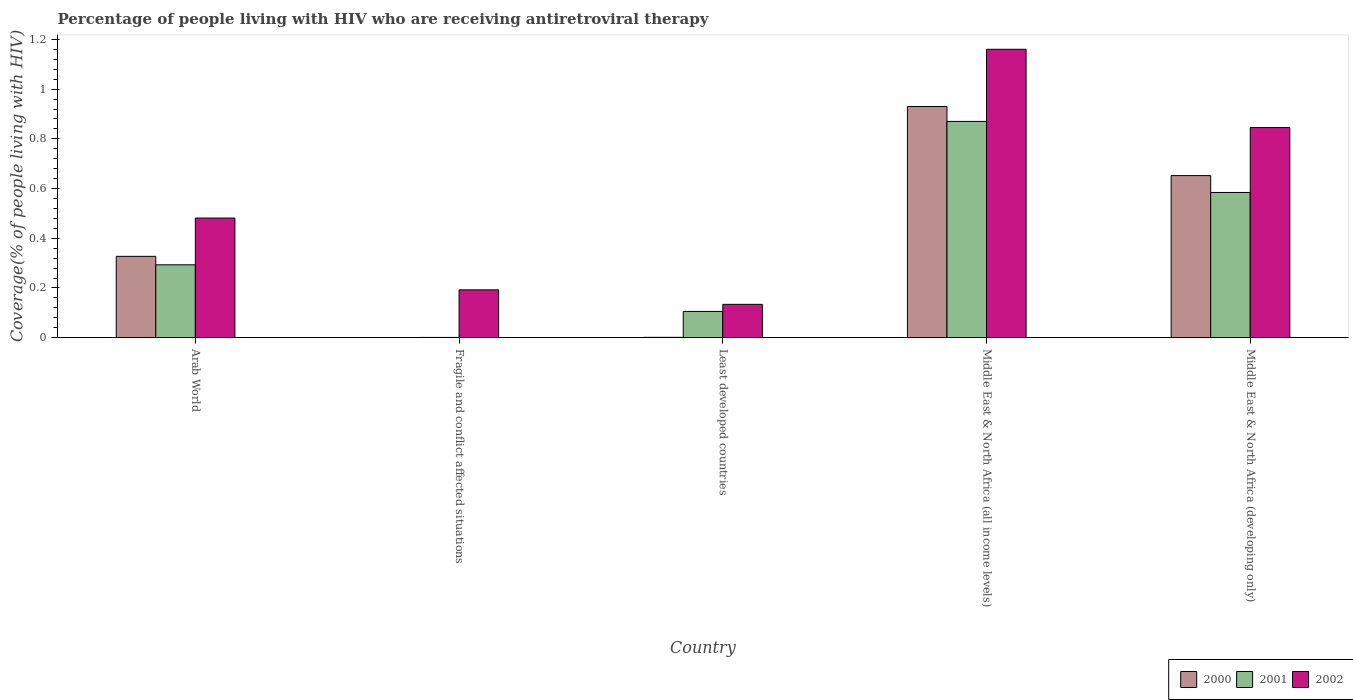Are the number of bars on each tick of the X-axis equal?
Provide a succinct answer. Yes. How many bars are there on the 1st tick from the right?
Keep it short and to the point. 3. What is the label of the 4th group of bars from the left?
Keep it short and to the point. Middle East & North Africa (all income levels). What is the percentage of the HIV infected people who are receiving antiretroviral therapy in 2002 in Least developed countries?
Make the answer very short. 0.13. Across all countries, what is the maximum percentage of the HIV infected people who are receiving antiretroviral therapy in 2001?
Ensure brevity in your answer.  0.87. Across all countries, what is the minimum percentage of the HIV infected people who are receiving antiretroviral therapy in 2001?
Give a very brief answer. 0. In which country was the percentage of the HIV infected people who are receiving antiretroviral therapy in 2002 maximum?
Provide a succinct answer. Middle East & North Africa (all income levels). In which country was the percentage of the HIV infected people who are receiving antiretroviral therapy in 2000 minimum?
Your response must be concise. Fragile and conflict affected situations. What is the total percentage of the HIV infected people who are receiving antiretroviral therapy in 2001 in the graph?
Make the answer very short. 1.85. What is the difference between the percentage of the HIV infected people who are receiving antiretroviral therapy in 2000 in Middle East & North Africa (all income levels) and that in Middle East & North Africa (developing only)?
Keep it short and to the point. 0.28. What is the difference between the percentage of the HIV infected people who are receiving antiretroviral therapy in 2002 in Middle East & North Africa (developing only) and the percentage of the HIV infected people who are receiving antiretroviral therapy in 2000 in Fragile and conflict affected situations?
Ensure brevity in your answer.  0.85. What is the average percentage of the HIV infected people who are receiving antiretroviral therapy in 2000 per country?
Give a very brief answer. 0.38. What is the difference between the percentage of the HIV infected people who are receiving antiretroviral therapy of/in 2001 and percentage of the HIV infected people who are receiving antiretroviral therapy of/in 2002 in Fragile and conflict affected situations?
Give a very brief answer. -0.19. What is the ratio of the percentage of the HIV infected people who are receiving antiretroviral therapy in 2002 in Arab World to that in Fragile and conflict affected situations?
Provide a short and direct response. 2.5. Is the percentage of the HIV infected people who are receiving antiretroviral therapy in 2000 in Fragile and conflict affected situations less than that in Middle East & North Africa (all income levels)?
Offer a very short reply. Yes. Is the difference between the percentage of the HIV infected people who are receiving antiretroviral therapy in 2001 in Least developed countries and Middle East & North Africa (developing only) greater than the difference between the percentage of the HIV infected people who are receiving antiretroviral therapy in 2002 in Least developed countries and Middle East & North Africa (developing only)?
Provide a short and direct response. Yes. What is the difference between the highest and the second highest percentage of the HIV infected people who are receiving antiretroviral therapy in 2000?
Your answer should be compact. 0.28. What is the difference between the highest and the lowest percentage of the HIV infected people who are receiving antiretroviral therapy in 2001?
Offer a terse response. 0.87. In how many countries, is the percentage of the HIV infected people who are receiving antiretroviral therapy in 2002 greater than the average percentage of the HIV infected people who are receiving antiretroviral therapy in 2002 taken over all countries?
Give a very brief answer. 2. What does the 2nd bar from the left in Fragile and conflict affected situations represents?
Offer a very short reply. 2001. What does the 2nd bar from the right in Middle East & North Africa (developing only) represents?
Offer a very short reply. 2001. Is it the case that in every country, the sum of the percentage of the HIV infected people who are receiving antiretroviral therapy in 2000 and percentage of the HIV infected people who are receiving antiretroviral therapy in 2001 is greater than the percentage of the HIV infected people who are receiving antiretroviral therapy in 2002?
Provide a succinct answer. No. Are the values on the major ticks of Y-axis written in scientific E-notation?
Provide a short and direct response. No. Does the graph contain grids?
Give a very brief answer. No. Where does the legend appear in the graph?
Provide a short and direct response. Bottom right. How many legend labels are there?
Provide a short and direct response. 3. What is the title of the graph?
Your answer should be very brief. Percentage of people living with HIV who are receiving antiretroviral therapy. What is the label or title of the Y-axis?
Offer a very short reply. Coverage(% of people living with HIV). What is the Coverage(% of people living with HIV) in 2000 in Arab World?
Offer a very short reply. 0.33. What is the Coverage(% of people living with HIV) in 2001 in Arab World?
Offer a very short reply. 0.29. What is the Coverage(% of people living with HIV) in 2002 in Arab World?
Provide a short and direct response. 0.48. What is the Coverage(% of people living with HIV) of 2000 in Fragile and conflict affected situations?
Keep it short and to the point. 0. What is the Coverage(% of people living with HIV) in 2001 in Fragile and conflict affected situations?
Your answer should be very brief. 0. What is the Coverage(% of people living with HIV) in 2002 in Fragile and conflict affected situations?
Provide a succinct answer. 0.19. What is the Coverage(% of people living with HIV) of 2000 in Least developed countries?
Ensure brevity in your answer.  0. What is the Coverage(% of people living with HIV) of 2001 in Least developed countries?
Ensure brevity in your answer.  0.11. What is the Coverage(% of people living with HIV) in 2002 in Least developed countries?
Give a very brief answer. 0.13. What is the Coverage(% of people living with HIV) in 2000 in Middle East & North Africa (all income levels)?
Your response must be concise. 0.93. What is the Coverage(% of people living with HIV) of 2001 in Middle East & North Africa (all income levels)?
Offer a terse response. 0.87. What is the Coverage(% of people living with HIV) of 2002 in Middle East & North Africa (all income levels)?
Your response must be concise. 1.16. What is the Coverage(% of people living with HIV) in 2000 in Middle East & North Africa (developing only)?
Your answer should be compact. 0.65. What is the Coverage(% of people living with HIV) in 2001 in Middle East & North Africa (developing only)?
Your answer should be very brief. 0.58. What is the Coverage(% of people living with HIV) in 2002 in Middle East & North Africa (developing only)?
Your response must be concise. 0.85. Across all countries, what is the maximum Coverage(% of people living with HIV) in 2000?
Provide a short and direct response. 0.93. Across all countries, what is the maximum Coverage(% of people living with HIV) of 2001?
Offer a very short reply. 0.87. Across all countries, what is the maximum Coverage(% of people living with HIV) of 2002?
Make the answer very short. 1.16. Across all countries, what is the minimum Coverage(% of people living with HIV) in 2000?
Provide a short and direct response. 0. Across all countries, what is the minimum Coverage(% of people living with HIV) of 2001?
Your answer should be very brief. 0. Across all countries, what is the minimum Coverage(% of people living with HIV) in 2002?
Your response must be concise. 0.13. What is the total Coverage(% of people living with HIV) of 2000 in the graph?
Keep it short and to the point. 1.91. What is the total Coverage(% of people living with HIV) of 2001 in the graph?
Offer a very short reply. 1.85. What is the total Coverage(% of people living with HIV) in 2002 in the graph?
Offer a terse response. 2.81. What is the difference between the Coverage(% of people living with HIV) in 2000 in Arab World and that in Fragile and conflict affected situations?
Your response must be concise. 0.33. What is the difference between the Coverage(% of people living with HIV) in 2001 in Arab World and that in Fragile and conflict affected situations?
Offer a very short reply. 0.29. What is the difference between the Coverage(% of people living with HIV) of 2002 in Arab World and that in Fragile and conflict affected situations?
Offer a very short reply. 0.29. What is the difference between the Coverage(% of people living with HIV) of 2000 in Arab World and that in Least developed countries?
Give a very brief answer. 0.33. What is the difference between the Coverage(% of people living with HIV) in 2001 in Arab World and that in Least developed countries?
Ensure brevity in your answer.  0.19. What is the difference between the Coverage(% of people living with HIV) of 2002 in Arab World and that in Least developed countries?
Your answer should be very brief. 0.35. What is the difference between the Coverage(% of people living with HIV) in 2000 in Arab World and that in Middle East & North Africa (all income levels)?
Your response must be concise. -0.6. What is the difference between the Coverage(% of people living with HIV) in 2001 in Arab World and that in Middle East & North Africa (all income levels)?
Give a very brief answer. -0.58. What is the difference between the Coverage(% of people living with HIV) in 2002 in Arab World and that in Middle East & North Africa (all income levels)?
Ensure brevity in your answer.  -0.68. What is the difference between the Coverage(% of people living with HIV) of 2000 in Arab World and that in Middle East & North Africa (developing only)?
Provide a short and direct response. -0.32. What is the difference between the Coverage(% of people living with HIV) of 2001 in Arab World and that in Middle East & North Africa (developing only)?
Provide a succinct answer. -0.29. What is the difference between the Coverage(% of people living with HIV) of 2002 in Arab World and that in Middle East & North Africa (developing only)?
Provide a succinct answer. -0.36. What is the difference between the Coverage(% of people living with HIV) in 2000 in Fragile and conflict affected situations and that in Least developed countries?
Give a very brief answer. -0. What is the difference between the Coverage(% of people living with HIV) of 2001 in Fragile and conflict affected situations and that in Least developed countries?
Your answer should be very brief. -0.1. What is the difference between the Coverage(% of people living with HIV) in 2002 in Fragile and conflict affected situations and that in Least developed countries?
Provide a short and direct response. 0.06. What is the difference between the Coverage(% of people living with HIV) in 2000 in Fragile and conflict affected situations and that in Middle East & North Africa (all income levels)?
Your answer should be compact. -0.93. What is the difference between the Coverage(% of people living with HIV) in 2001 in Fragile and conflict affected situations and that in Middle East & North Africa (all income levels)?
Make the answer very short. -0.87. What is the difference between the Coverage(% of people living with HIV) of 2002 in Fragile and conflict affected situations and that in Middle East & North Africa (all income levels)?
Ensure brevity in your answer.  -0.97. What is the difference between the Coverage(% of people living with HIV) of 2000 in Fragile and conflict affected situations and that in Middle East & North Africa (developing only)?
Offer a very short reply. -0.65. What is the difference between the Coverage(% of people living with HIV) in 2001 in Fragile and conflict affected situations and that in Middle East & North Africa (developing only)?
Your response must be concise. -0.58. What is the difference between the Coverage(% of people living with HIV) of 2002 in Fragile and conflict affected situations and that in Middle East & North Africa (developing only)?
Your answer should be very brief. -0.65. What is the difference between the Coverage(% of people living with HIV) of 2000 in Least developed countries and that in Middle East & North Africa (all income levels)?
Your response must be concise. -0.93. What is the difference between the Coverage(% of people living with HIV) in 2001 in Least developed countries and that in Middle East & North Africa (all income levels)?
Provide a succinct answer. -0.76. What is the difference between the Coverage(% of people living with HIV) in 2002 in Least developed countries and that in Middle East & North Africa (all income levels)?
Your response must be concise. -1.03. What is the difference between the Coverage(% of people living with HIV) in 2000 in Least developed countries and that in Middle East & North Africa (developing only)?
Ensure brevity in your answer.  -0.65. What is the difference between the Coverage(% of people living with HIV) in 2001 in Least developed countries and that in Middle East & North Africa (developing only)?
Your answer should be compact. -0.48. What is the difference between the Coverage(% of people living with HIV) of 2002 in Least developed countries and that in Middle East & North Africa (developing only)?
Provide a succinct answer. -0.71. What is the difference between the Coverage(% of people living with HIV) in 2000 in Middle East & North Africa (all income levels) and that in Middle East & North Africa (developing only)?
Your response must be concise. 0.28. What is the difference between the Coverage(% of people living with HIV) in 2001 in Middle East & North Africa (all income levels) and that in Middle East & North Africa (developing only)?
Keep it short and to the point. 0.29. What is the difference between the Coverage(% of people living with HIV) of 2002 in Middle East & North Africa (all income levels) and that in Middle East & North Africa (developing only)?
Offer a terse response. 0.31. What is the difference between the Coverage(% of people living with HIV) in 2000 in Arab World and the Coverage(% of people living with HIV) in 2001 in Fragile and conflict affected situations?
Offer a terse response. 0.33. What is the difference between the Coverage(% of people living with HIV) in 2000 in Arab World and the Coverage(% of people living with HIV) in 2002 in Fragile and conflict affected situations?
Your answer should be very brief. 0.13. What is the difference between the Coverage(% of people living with HIV) in 2001 in Arab World and the Coverage(% of people living with HIV) in 2002 in Fragile and conflict affected situations?
Keep it short and to the point. 0.1. What is the difference between the Coverage(% of people living with HIV) in 2000 in Arab World and the Coverage(% of people living with HIV) in 2001 in Least developed countries?
Keep it short and to the point. 0.22. What is the difference between the Coverage(% of people living with HIV) in 2000 in Arab World and the Coverage(% of people living with HIV) in 2002 in Least developed countries?
Your answer should be compact. 0.19. What is the difference between the Coverage(% of people living with HIV) of 2001 in Arab World and the Coverage(% of people living with HIV) of 2002 in Least developed countries?
Provide a succinct answer. 0.16. What is the difference between the Coverage(% of people living with HIV) of 2000 in Arab World and the Coverage(% of people living with HIV) of 2001 in Middle East & North Africa (all income levels)?
Ensure brevity in your answer.  -0.54. What is the difference between the Coverage(% of people living with HIV) in 2000 in Arab World and the Coverage(% of people living with HIV) in 2002 in Middle East & North Africa (all income levels)?
Offer a very short reply. -0.83. What is the difference between the Coverage(% of people living with HIV) of 2001 in Arab World and the Coverage(% of people living with HIV) of 2002 in Middle East & North Africa (all income levels)?
Your response must be concise. -0.87. What is the difference between the Coverage(% of people living with HIV) in 2000 in Arab World and the Coverage(% of people living with HIV) in 2001 in Middle East & North Africa (developing only)?
Provide a short and direct response. -0.26. What is the difference between the Coverage(% of people living with HIV) in 2000 in Arab World and the Coverage(% of people living with HIV) in 2002 in Middle East & North Africa (developing only)?
Make the answer very short. -0.52. What is the difference between the Coverage(% of people living with HIV) in 2001 in Arab World and the Coverage(% of people living with HIV) in 2002 in Middle East & North Africa (developing only)?
Keep it short and to the point. -0.55. What is the difference between the Coverage(% of people living with HIV) in 2000 in Fragile and conflict affected situations and the Coverage(% of people living with HIV) in 2001 in Least developed countries?
Your answer should be very brief. -0.1. What is the difference between the Coverage(% of people living with HIV) in 2000 in Fragile and conflict affected situations and the Coverage(% of people living with HIV) in 2002 in Least developed countries?
Provide a succinct answer. -0.13. What is the difference between the Coverage(% of people living with HIV) in 2001 in Fragile and conflict affected situations and the Coverage(% of people living with HIV) in 2002 in Least developed countries?
Your answer should be compact. -0.13. What is the difference between the Coverage(% of people living with HIV) in 2000 in Fragile and conflict affected situations and the Coverage(% of people living with HIV) in 2001 in Middle East & North Africa (all income levels)?
Offer a terse response. -0.87. What is the difference between the Coverage(% of people living with HIV) in 2000 in Fragile and conflict affected situations and the Coverage(% of people living with HIV) in 2002 in Middle East & North Africa (all income levels)?
Provide a short and direct response. -1.16. What is the difference between the Coverage(% of people living with HIV) in 2001 in Fragile and conflict affected situations and the Coverage(% of people living with HIV) in 2002 in Middle East & North Africa (all income levels)?
Your answer should be compact. -1.16. What is the difference between the Coverage(% of people living with HIV) in 2000 in Fragile and conflict affected situations and the Coverage(% of people living with HIV) in 2001 in Middle East & North Africa (developing only)?
Your response must be concise. -0.58. What is the difference between the Coverage(% of people living with HIV) in 2000 in Fragile and conflict affected situations and the Coverage(% of people living with HIV) in 2002 in Middle East & North Africa (developing only)?
Ensure brevity in your answer.  -0.85. What is the difference between the Coverage(% of people living with HIV) of 2001 in Fragile and conflict affected situations and the Coverage(% of people living with HIV) of 2002 in Middle East & North Africa (developing only)?
Your response must be concise. -0.84. What is the difference between the Coverage(% of people living with HIV) in 2000 in Least developed countries and the Coverage(% of people living with HIV) in 2001 in Middle East & North Africa (all income levels)?
Provide a succinct answer. -0.87. What is the difference between the Coverage(% of people living with HIV) of 2000 in Least developed countries and the Coverage(% of people living with HIV) of 2002 in Middle East & North Africa (all income levels)?
Offer a terse response. -1.16. What is the difference between the Coverage(% of people living with HIV) of 2001 in Least developed countries and the Coverage(% of people living with HIV) of 2002 in Middle East & North Africa (all income levels)?
Offer a very short reply. -1.05. What is the difference between the Coverage(% of people living with HIV) in 2000 in Least developed countries and the Coverage(% of people living with HIV) in 2001 in Middle East & North Africa (developing only)?
Your response must be concise. -0.58. What is the difference between the Coverage(% of people living with HIV) of 2000 in Least developed countries and the Coverage(% of people living with HIV) of 2002 in Middle East & North Africa (developing only)?
Provide a short and direct response. -0.84. What is the difference between the Coverage(% of people living with HIV) of 2001 in Least developed countries and the Coverage(% of people living with HIV) of 2002 in Middle East & North Africa (developing only)?
Offer a terse response. -0.74. What is the difference between the Coverage(% of people living with HIV) of 2000 in Middle East & North Africa (all income levels) and the Coverage(% of people living with HIV) of 2001 in Middle East & North Africa (developing only)?
Provide a succinct answer. 0.35. What is the difference between the Coverage(% of people living with HIV) of 2000 in Middle East & North Africa (all income levels) and the Coverage(% of people living with HIV) of 2002 in Middle East & North Africa (developing only)?
Your answer should be compact. 0.08. What is the difference between the Coverage(% of people living with HIV) in 2001 in Middle East & North Africa (all income levels) and the Coverage(% of people living with HIV) in 2002 in Middle East & North Africa (developing only)?
Provide a succinct answer. 0.02. What is the average Coverage(% of people living with HIV) of 2000 per country?
Your answer should be very brief. 0.38. What is the average Coverage(% of people living with HIV) in 2001 per country?
Provide a short and direct response. 0.37. What is the average Coverage(% of people living with HIV) in 2002 per country?
Offer a terse response. 0.56. What is the difference between the Coverage(% of people living with HIV) in 2000 and Coverage(% of people living with HIV) in 2001 in Arab World?
Your response must be concise. 0.03. What is the difference between the Coverage(% of people living with HIV) of 2000 and Coverage(% of people living with HIV) of 2002 in Arab World?
Ensure brevity in your answer.  -0.15. What is the difference between the Coverage(% of people living with HIV) of 2001 and Coverage(% of people living with HIV) of 2002 in Arab World?
Provide a short and direct response. -0.19. What is the difference between the Coverage(% of people living with HIV) of 2000 and Coverage(% of people living with HIV) of 2001 in Fragile and conflict affected situations?
Ensure brevity in your answer.  -0. What is the difference between the Coverage(% of people living with HIV) in 2000 and Coverage(% of people living with HIV) in 2002 in Fragile and conflict affected situations?
Your response must be concise. -0.19. What is the difference between the Coverage(% of people living with HIV) in 2001 and Coverage(% of people living with HIV) in 2002 in Fragile and conflict affected situations?
Provide a short and direct response. -0.19. What is the difference between the Coverage(% of people living with HIV) in 2000 and Coverage(% of people living with HIV) in 2001 in Least developed countries?
Your response must be concise. -0.1. What is the difference between the Coverage(% of people living with HIV) in 2000 and Coverage(% of people living with HIV) in 2002 in Least developed countries?
Offer a very short reply. -0.13. What is the difference between the Coverage(% of people living with HIV) in 2001 and Coverage(% of people living with HIV) in 2002 in Least developed countries?
Your answer should be very brief. -0.03. What is the difference between the Coverage(% of people living with HIV) of 2000 and Coverage(% of people living with HIV) of 2001 in Middle East & North Africa (all income levels)?
Ensure brevity in your answer.  0.06. What is the difference between the Coverage(% of people living with HIV) in 2000 and Coverage(% of people living with HIV) in 2002 in Middle East & North Africa (all income levels)?
Keep it short and to the point. -0.23. What is the difference between the Coverage(% of people living with HIV) of 2001 and Coverage(% of people living with HIV) of 2002 in Middle East & North Africa (all income levels)?
Ensure brevity in your answer.  -0.29. What is the difference between the Coverage(% of people living with HIV) in 2000 and Coverage(% of people living with HIV) in 2001 in Middle East & North Africa (developing only)?
Give a very brief answer. 0.07. What is the difference between the Coverage(% of people living with HIV) in 2000 and Coverage(% of people living with HIV) in 2002 in Middle East & North Africa (developing only)?
Make the answer very short. -0.19. What is the difference between the Coverage(% of people living with HIV) of 2001 and Coverage(% of people living with HIV) of 2002 in Middle East & North Africa (developing only)?
Make the answer very short. -0.26. What is the ratio of the Coverage(% of people living with HIV) in 2000 in Arab World to that in Fragile and conflict affected situations?
Provide a succinct answer. 679.72. What is the ratio of the Coverage(% of people living with HIV) in 2001 in Arab World to that in Fragile and conflict affected situations?
Ensure brevity in your answer.  310.29. What is the ratio of the Coverage(% of people living with HIV) in 2002 in Arab World to that in Fragile and conflict affected situations?
Give a very brief answer. 2.5. What is the ratio of the Coverage(% of people living with HIV) of 2000 in Arab World to that in Least developed countries?
Your answer should be very brief. 245.99. What is the ratio of the Coverage(% of people living with HIV) in 2001 in Arab World to that in Least developed countries?
Make the answer very short. 2.78. What is the ratio of the Coverage(% of people living with HIV) of 2002 in Arab World to that in Least developed countries?
Provide a short and direct response. 3.59. What is the ratio of the Coverage(% of people living with HIV) in 2000 in Arab World to that in Middle East & North Africa (all income levels)?
Your answer should be compact. 0.35. What is the ratio of the Coverage(% of people living with HIV) in 2001 in Arab World to that in Middle East & North Africa (all income levels)?
Ensure brevity in your answer.  0.34. What is the ratio of the Coverage(% of people living with HIV) in 2002 in Arab World to that in Middle East & North Africa (all income levels)?
Keep it short and to the point. 0.41. What is the ratio of the Coverage(% of people living with HIV) of 2000 in Arab World to that in Middle East & North Africa (developing only)?
Offer a very short reply. 0.5. What is the ratio of the Coverage(% of people living with HIV) of 2001 in Arab World to that in Middle East & North Africa (developing only)?
Keep it short and to the point. 0.5. What is the ratio of the Coverage(% of people living with HIV) in 2002 in Arab World to that in Middle East & North Africa (developing only)?
Ensure brevity in your answer.  0.57. What is the ratio of the Coverage(% of people living with HIV) in 2000 in Fragile and conflict affected situations to that in Least developed countries?
Provide a short and direct response. 0.36. What is the ratio of the Coverage(% of people living with HIV) in 2001 in Fragile and conflict affected situations to that in Least developed countries?
Your answer should be very brief. 0.01. What is the ratio of the Coverage(% of people living with HIV) of 2002 in Fragile and conflict affected situations to that in Least developed countries?
Keep it short and to the point. 1.43. What is the ratio of the Coverage(% of people living with HIV) of 2001 in Fragile and conflict affected situations to that in Middle East & North Africa (all income levels)?
Offer a terse response. 0. What is the ratio of the Coverage(% of people living with HIV) of 2002 in Fragile and conflict affected situations to that in Middle East & North Africa (all income levels)?
Offer a terse response. 0.17. What is the ratio of the Coverage(% of people living with HIV) in 2000 in Fragile and conflict affected situations to that in Middle East & North Africa (developing only)?
Your answer should be very brief. 0. What is the ratio of the Coverage(% of people living with HIV) in 2001 in Fragile and conflict affected situations to that in Middle East & North Africa (developing only)?
Offer a terse response. 0. What is the ratio of the Coverage(% of people living with HIV) of 2002 in Fragile and conflict affected situations to that in Middle East & North Africa (developing only)?
Offer a terse response. 0.23. What is the ratio of the Coverage(% of people living with HIV) in 2000 in Least developed countries to that in Middle East & North Africa (all income levels)?
Offer a very short reply. 0. What is the ratio of the Coverage(% of people living with HIV) of 2001 in Least developed countries to that in Middle East & North Africa (all income levels)?
Your answer should be compact. 0.12. What is the ratio of the Coverage(% of people living with HIV) of 2002 in Least developed countries to that in Middle East & North Africa (all income levels)?
Provide a succinct answer. 0.12. What is the ratio of the Coverage(% of people living with HIV) in 2000 in Least developed countries to that in Middle East & North Africa (developing only)?
Your answer should be very brief. 0. What is the ratio of the Coverage(% of people living with HIV) in 2001 in Least developed countries to that in Middle East & North Africa (developing only)?
Give a very brief answer. 0.18. What is the ratio of the Coverage(% of people living with HIV) of 2002 in Least developed countries to that in Middle East & North Africa (developing only)?
Your answer should be compact. 0.16. What is the ratio of the Coverage(% of people living with HIV) of 2000 in Middle East & North Africa (all income levels) to that in Middle East & North Africa (developing only)?
Keep it short and to the point. 1.43. What is the ratio of the Coverage(% of people living with HIV) of 2001 in Middle East & North Africa (all income levels) to that in Middle East & North Africa (developing only)?
Keep it short and to the point. 1.49. What is the ratio of the Coverage(% of people living with HIV) in 2002 in Middle East & North Africa (all income levels) to that in Middle East & North Africa (developing only)?
Keep it short and to the point. 1.37. What is the difference between the highest and the second highest Coverage(% of people living with HIV) in 2000?
Offer a very short reply. 0.28. What is the difference between the highest and the second highest Coverage(% of people living with HIV) in 2001?
Provide a succinct answer. 0.29. What is the difference between the highest and the second highest Coverage(% of people living with HIV) of 2002?
Provide a succinct answer. 0.31. What is the difference between the highest and the lowest Coverage(% of people living with HIV) in 2000?
Give a very brief answer. 0.93. What is the difference between the highest and the lowest Coverage(% of people living with HIV) of 2001?
Offer a very short reply. 0.87. What is the difference between the highest and the lowest Coverage(% of people living with HIV) of 2002?
Ensure brevity in your answer.  1.03. 